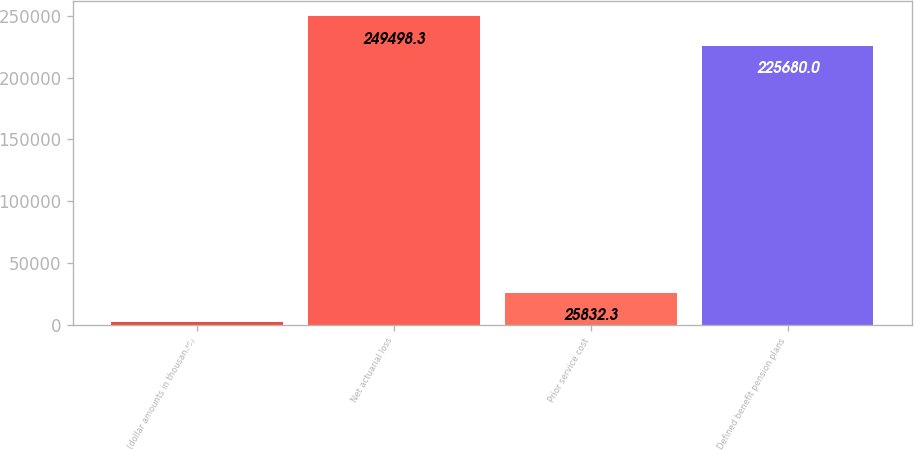Convert chart. <chart><loc_0><loc_0><loc_500><loc_500><bar_chart><fcel>(dollar amounts in thousands)<fcel>Net actuarial loss<fcel>Prior service cost<fcel>Defined benefit pension plans<nl><fcel>2014<fcel>249498<fcel>25832.3<fcel>225680<nl></chart> 